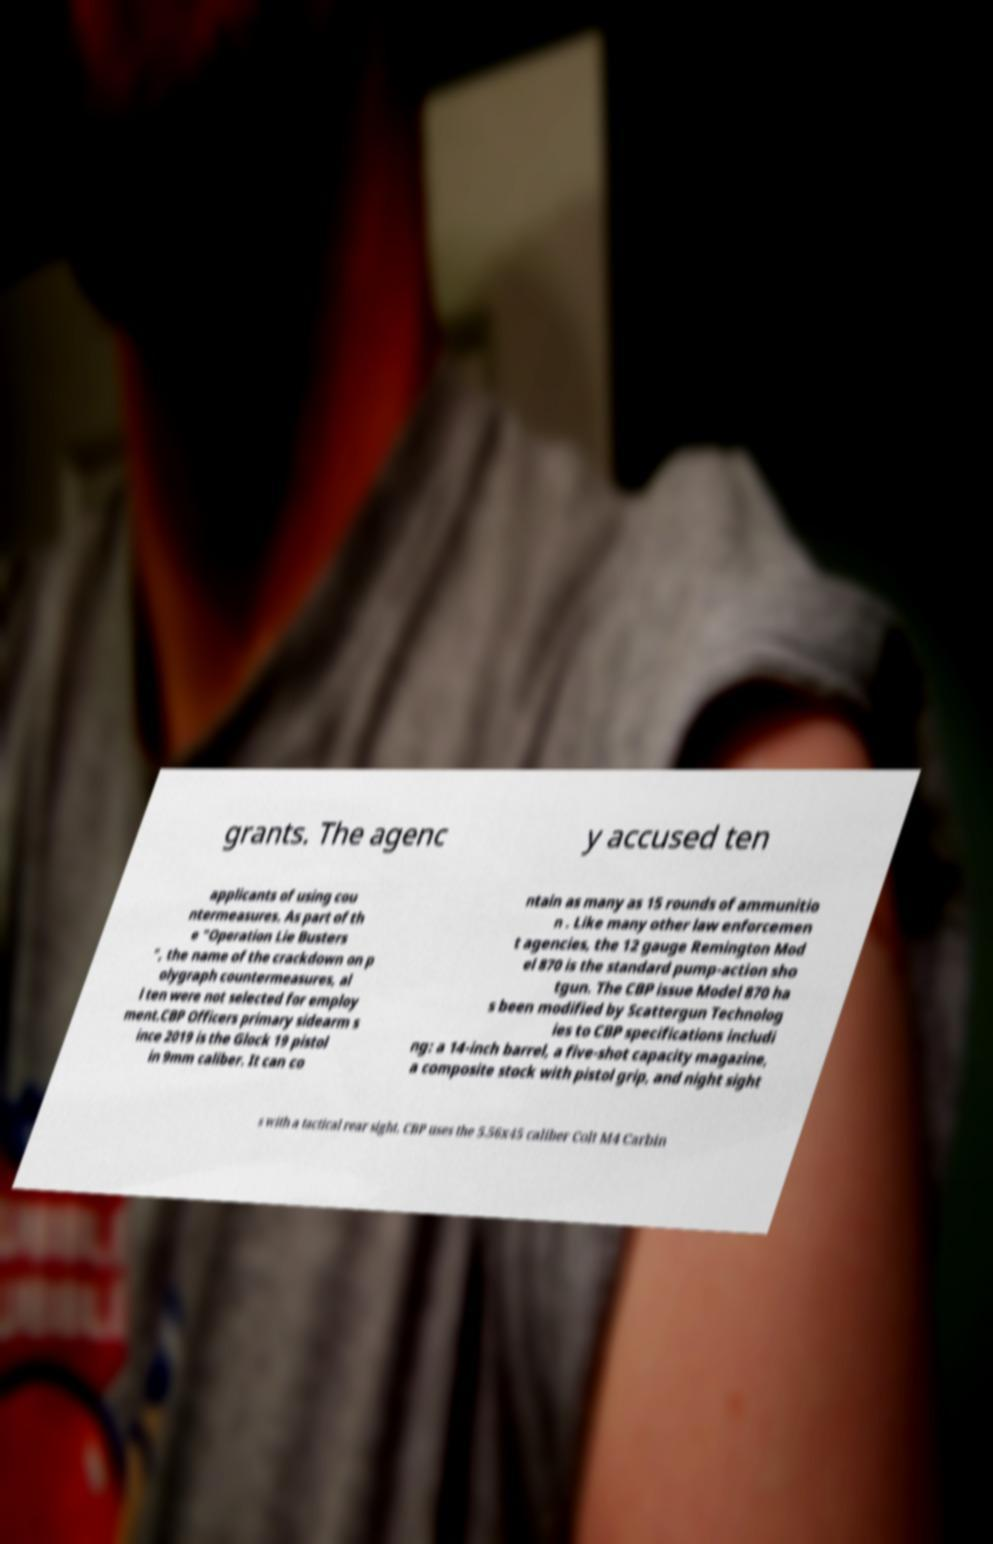Could you extract and type out the text from this image? grants. The agenc y accused ten applicants of using cou ntermeasures. As part of th e "Operation Lie Busters ", the name of the crackdown on p olygraph countermeasures, al l ten were not selected for employ ment.CBP Officers primary sidearm s ince 2019 is the Glock 19 pistol in 9mm caliber. It can co ntain as many as 15 rounds of ammunitio n . Like many other law enforcemen t agencies, the 12 gauge Remington Mod el 870 is the standard pump-action sho tgun. The CBP issue Model 870 ha s been modified by Scattergun Technolog ies to CBP specifications includi ng: a 14-inch barrel, a five-shot capacity magazine, a composite stock with pistol grip, and night sight s with a tactical rear sight. CBP uses the 5.56x45 caliber Colt M4 Carbin 